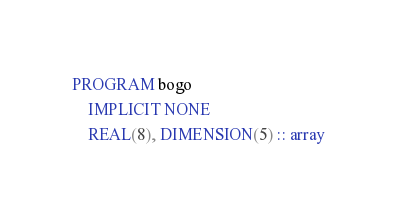Convert code to text. <code><loc_0><loc_0><loc_500><loc_500><_FORTRAN_>PROGRAM bogo
    IMPLICIT NONE
    REAL(8), DIMENSION(5) :: array
</code> 